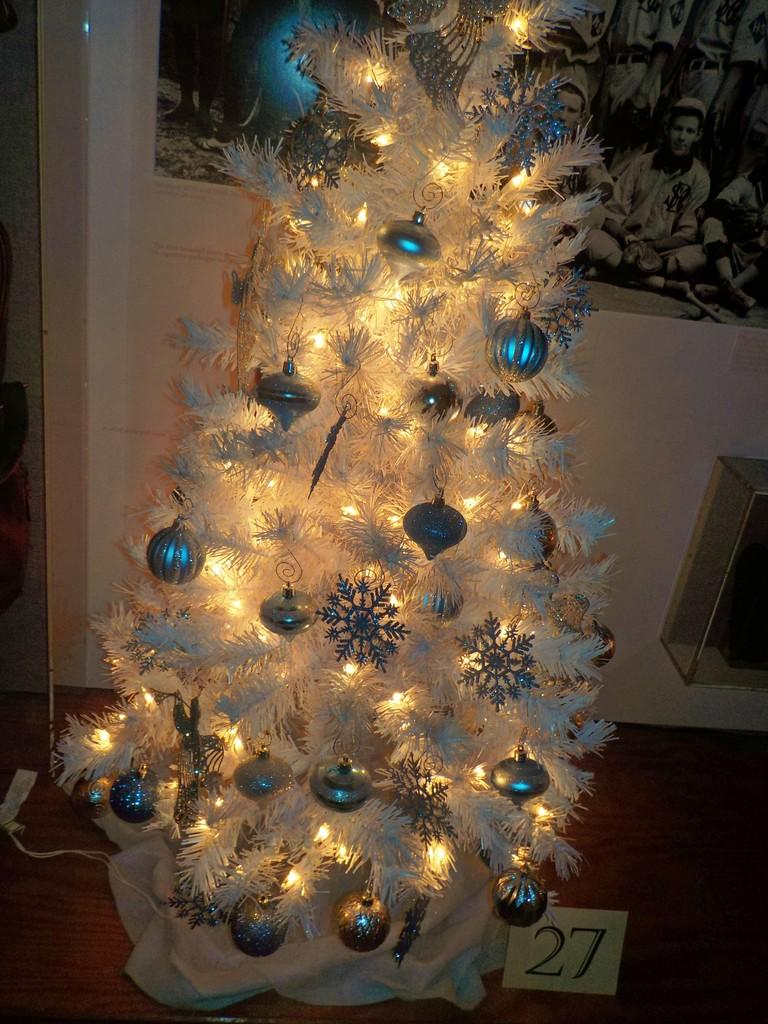What type of tree is in the image? There is a Christmas tree in the image. What is covering the Christmas tree? The Christmas tree has snowflakes. What are hanging from the Christmas tree? The Christmas tree has hanging balls. What other decorations are on the Christmas tree? The Christmas tree has other decorations. What can be seen on the wall in the image? There is a photo on the wall in the image. What trail can be seen in the image? There is no trail present in the image; it features a Christmas tree with decorations and a photo on the wall. 